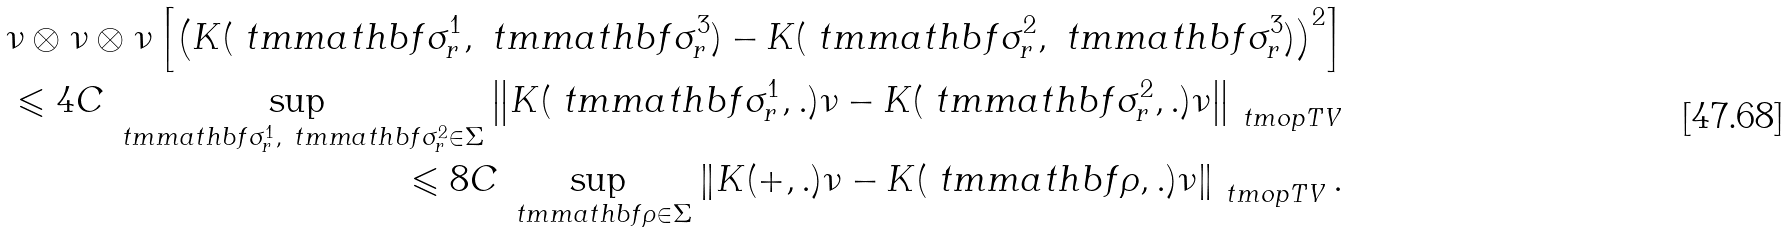<formula> <loc_0><loc_0><loc_500><loc_500>\nu \otimes \nu \otimes \nu \left [ \left ( K ( \ t m m a t h b f { \sigma } _ { r } ^ { 1 } , \ t m m a t h b f { \sigma } _ { r } ^ { 3 } ) - K ( \ t m m a t h b f { \sigma } _ { r } ^ { 2 } , \ t m m a t h b f { \sigma } _ { r } ^ { 3 } ) \right ) ^ { 2 } \right ] \\ \leqslant 4 C \sup _ { \ t m m a t h b f { \sigma } _ { r } ^ { 1 } , \ t m m a t h b f { \sigma } _ { r } ^ { 2 } \in \Sigma } \left \| K ( \ t m m a t h b f { \sigma } _ { r } ^ { 1 } , . ) \nu - K ( \ t m m a t h b f { \sigma } _ { r } ^ { 2 } , . ) \nu \right \| _ { \ t m o p { T V } } \\ \leqslant 8 C \sup _ { \ t m m a t h b f { \rho } \in \Sigma } \left \| K ( + , . ) \nu - K ( \ t m m a t h b f { \rho } , . ) \nu \right \| _ { \ t m o p { T V } } .</formula> 